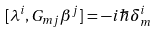Convert formula to latex. <formula><loc_0><loc_0><loc_500><loc_500>[ \lambda ^ { i } , G _ { m j } \beta ^ { j } ] = - i \hbar { \delta } ^ { i } _ { m }</formula> 